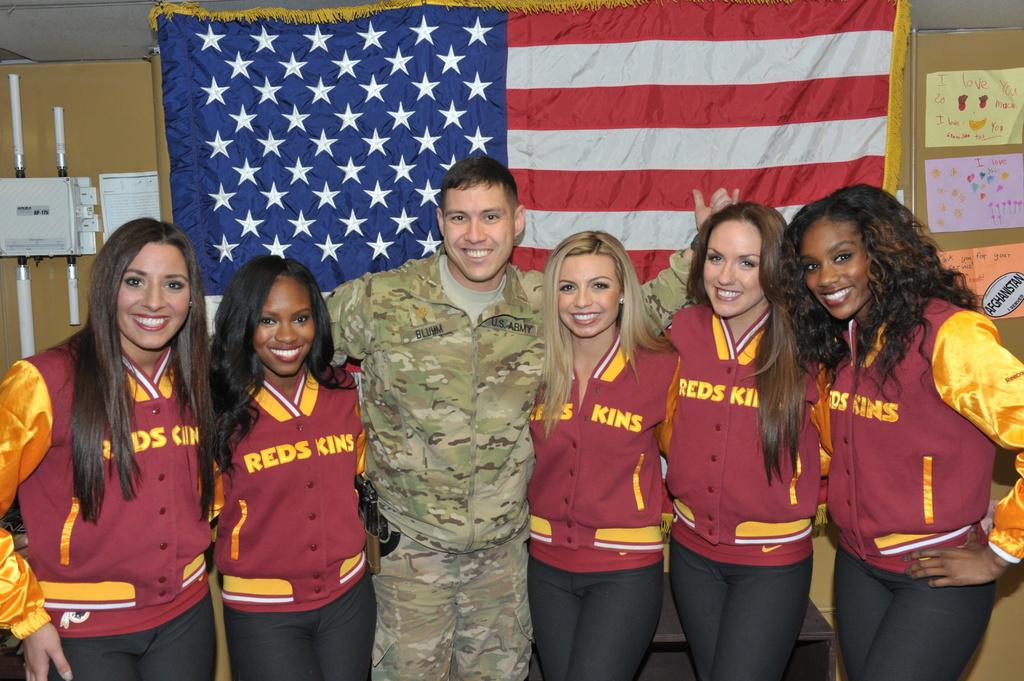<image>
Share a concise interpretation of the image provided. The girls posing with the man from the U.S. Army all have Red Skins jackets on. 